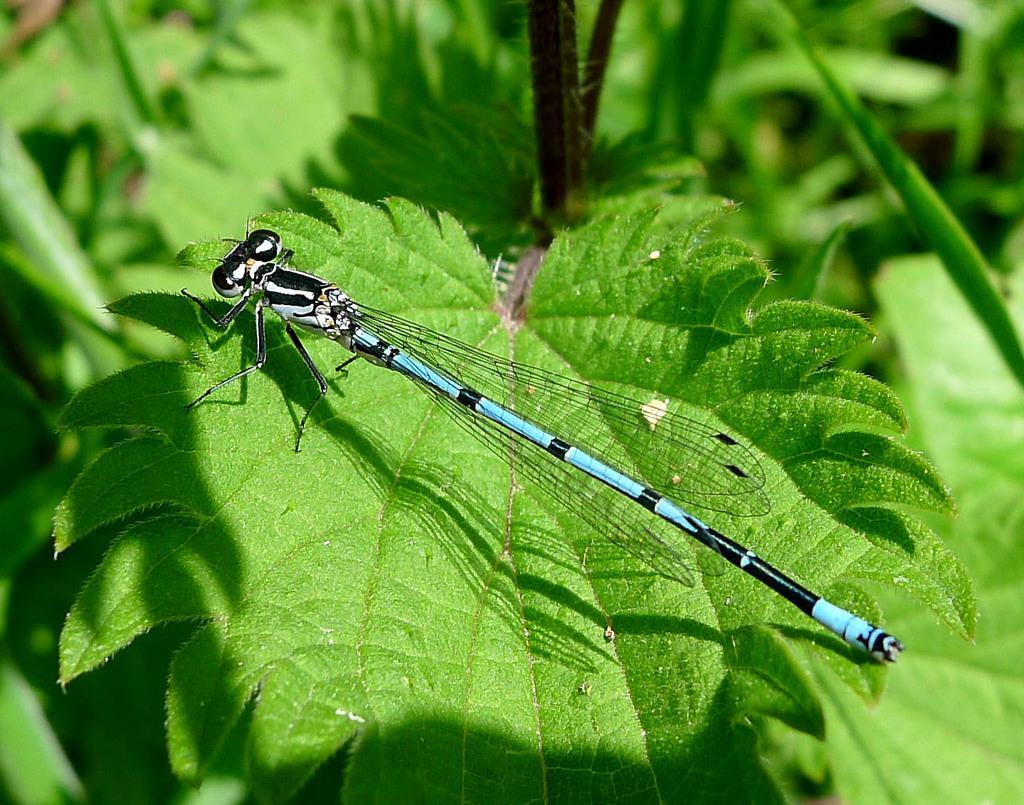Could you give a brief overview of what you see in this image? In this image I can see an insect on the leaf and the insect is in black, white and blue color and the leaves are in green color. 